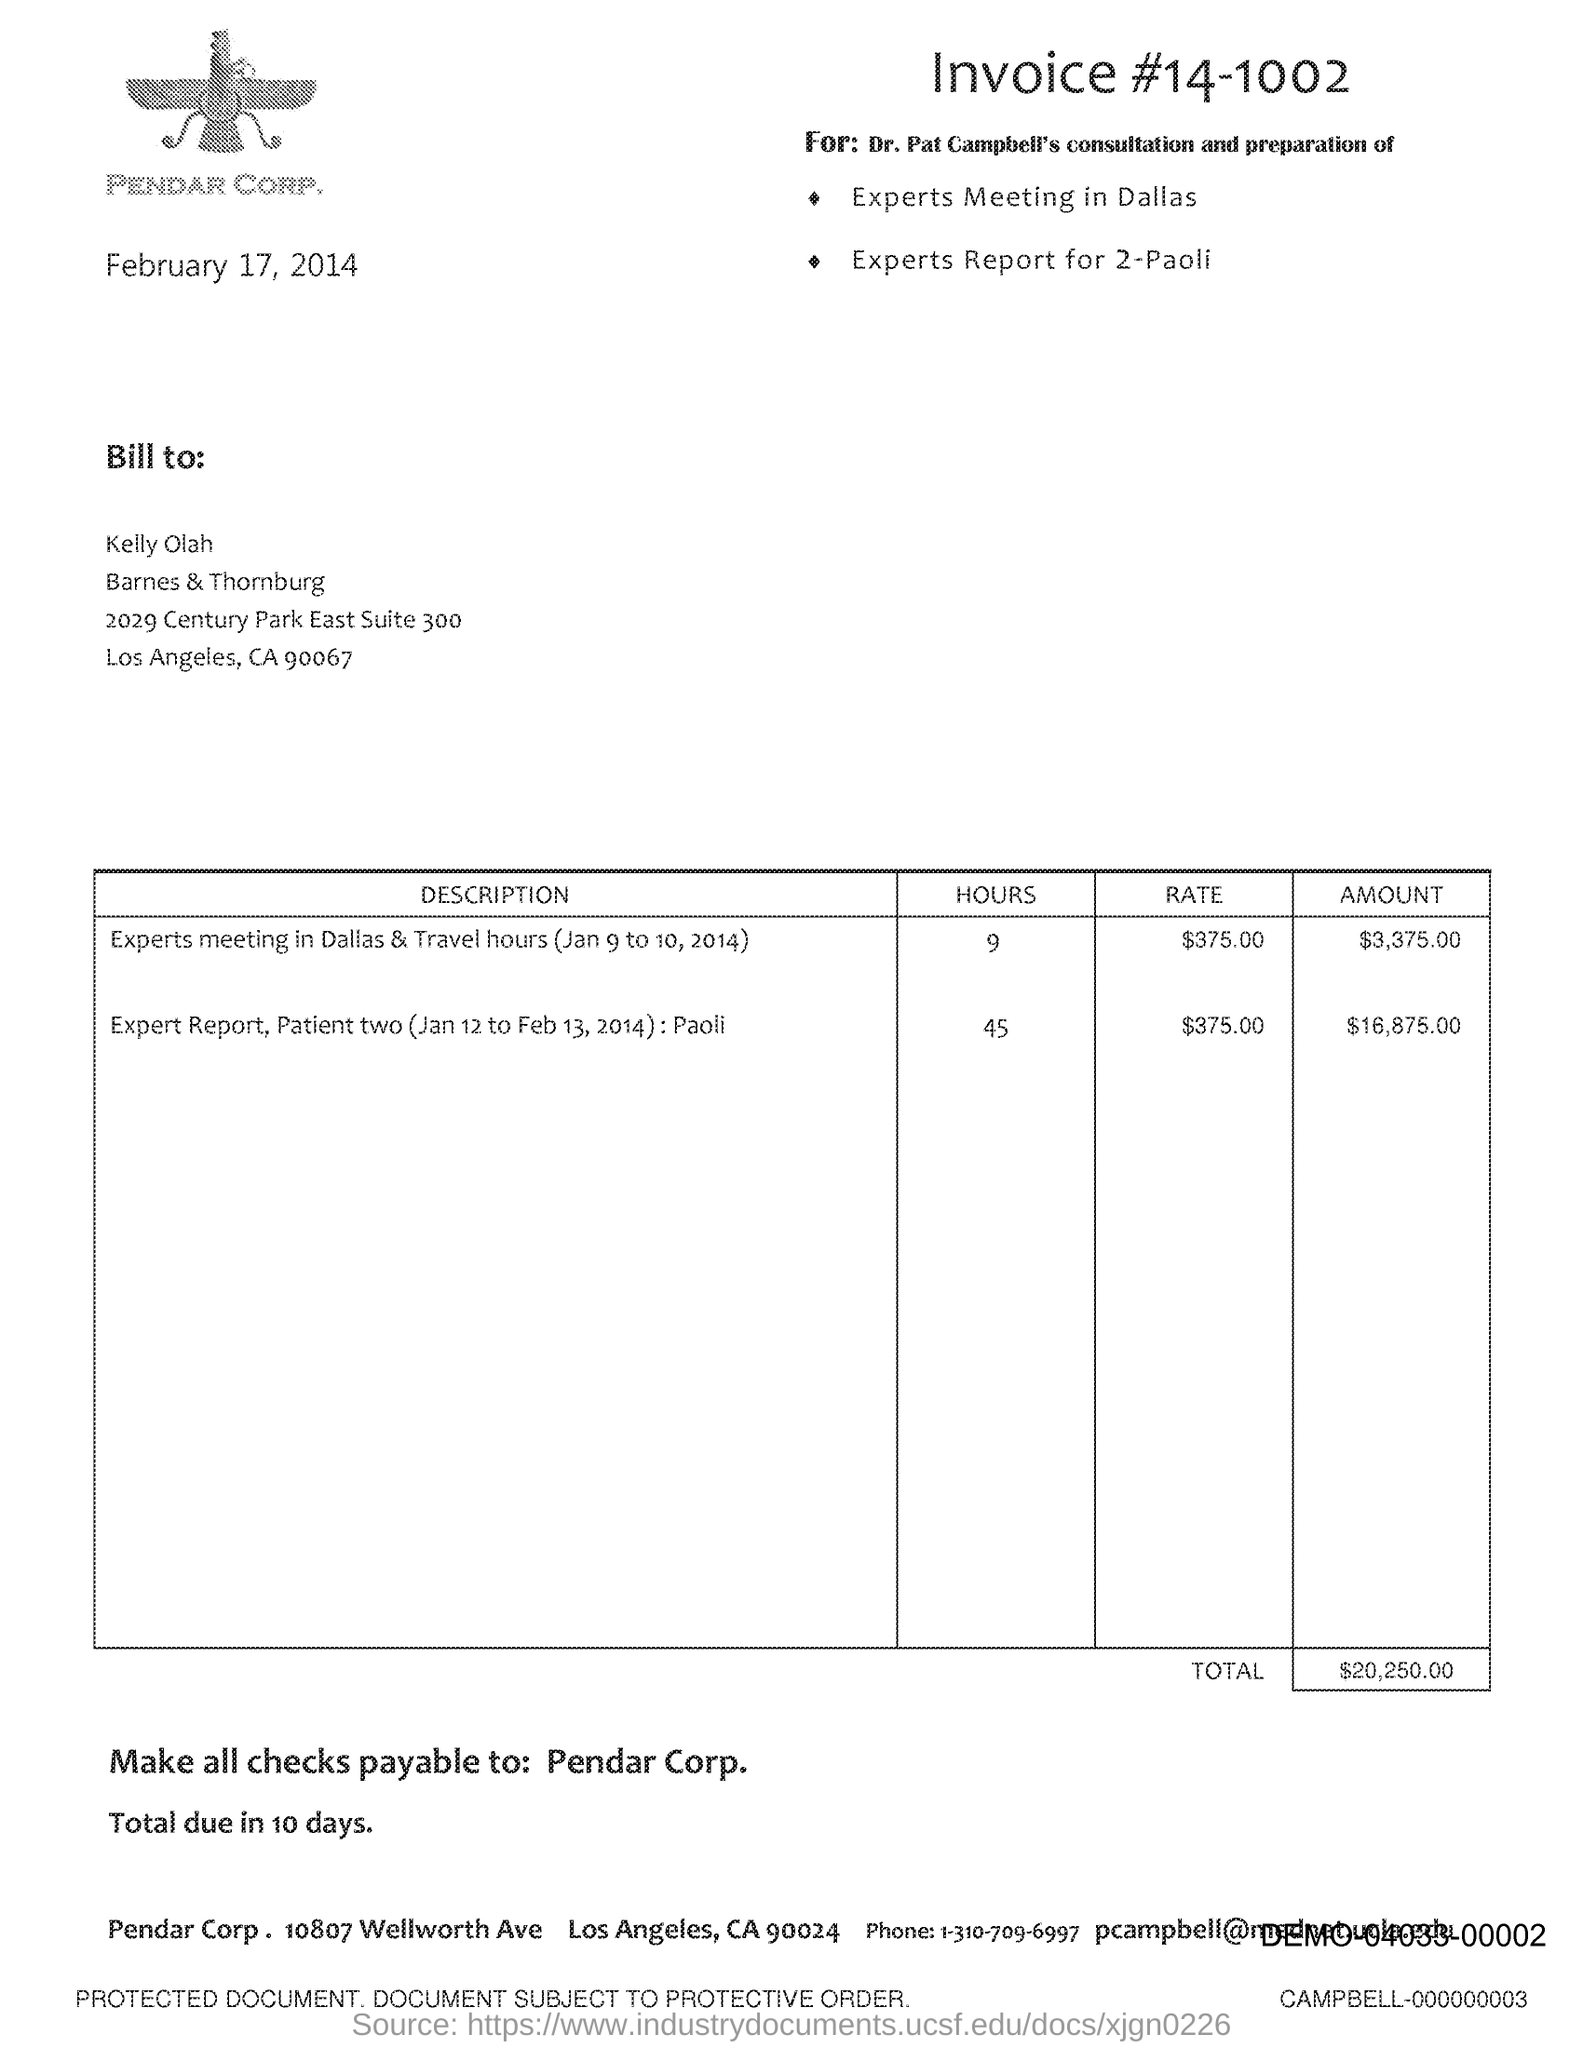What is the invoice number?
Provide a short and direct response. #14-1002. Which firm is mentioned at the top of the page?
Offer a very short reply. PENDAR CORP. When is the document dated?
Provide a succinct answer. February 17, 2014. To whom should it be billed?
Provide a short and direct response. Kelly Olah. What is the rate for experts meeting in Dallas & Travel hours?
Your answer should be compact. $375.00. What is the total amount for Expert report?
Your response must be concise. $16,875.00. To whom should checks be payable?
Your answer should be very brief. Pendar Corp. In how many days is the total due?
Give a very brief answer. 10. 